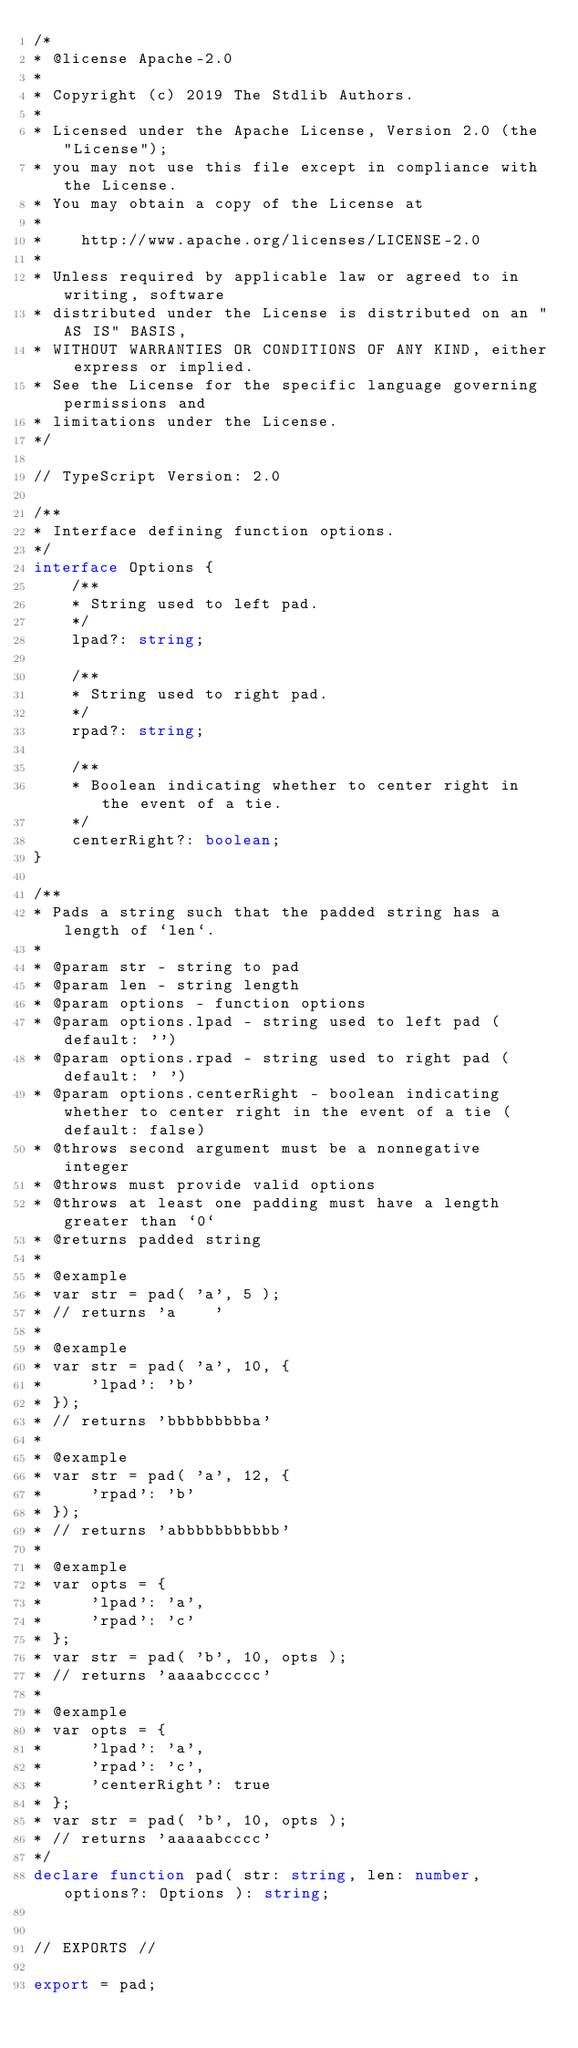<code> <loc_0><loc_0><loc_500><loc_500><_TypeScript_>/*
* @license Apache-2.0
*
* Copyright (c) 2019 The Stdlib Authors.
*
* Licensed under the Apache License, Version 2.0 (the "License");
* you may not use this file except in compliance with the License.
* You may obtain a copy of the License at
*
*    http://www.apache.org/licenses/LICENSE-2.0
*
* Unless required by applicable law or agreed to in writing, software
* distributed under the License is distributed on an "AS IS" BASIS,
* WITHOUT WARRANTIES OR CONDITIONS OF ANY KIND, either express or implied.
* See the License for the specific language governing permissions and
* limitations under the License.
*/

// TypeScript Version: 2.0

/**
* Interface defining function options.
*/
interface Options {
	/**
	* String used to left pad.
	*/
	lpad?: string;

	/**
	* String used to right pad.
	*/
	rpad?: string;

	/**
	* Boolean indicating whether to center right in the event of a tie.
	*/
	centerRight?: boolean;
}

/**
* Pads a string such that the padded string has a length of `len`.
*
* @param str - string to pad
* @param len - string length
* @param options - function options
* @param options.lpad - string used to left pad (default: '')
* @param options.rpad - string used to right pad (default: ' ')
* @param options.centerRight - boolean indicating whether to center right in the event of a tie (default: false)
* @throws second argument must be a nonnegative integer
* @throws must provide valid options
* @throws at least one padding must have a length greater than `0`
* @returns padded string
*
* @example
* var str = pad( 'a', 5 );
* // returns 'a    '
*
* @example
* var str = pad( 'a', 10, {
*     'lpad': 'b'
* });
* // returns 'bbbbbbbbba'
*
* @example
* var str = pad( 'a', 12, {
*     'rpad': 'b'
* });
* // returns 'abbbbbbbbbbb'
*
* @example
* var opts = {
*     'lpad': 'a',
*     'rpad': 'c'
* };
* var str = pad( 'b', 10, opts );
* // returns 'aaaabccccc'
*
* @example
* var opts = {
*     'lpad': 'a',
*     'rpad': 'c',
*     'centerRight': true
* };
* var str = pad( 'b', 10, opts );
* // returns 'aaaaabcccc'
*/
declare function pad( str: string, len: number, options?: Options ): string;


// EXPORTS //

export = pad;
</code> 